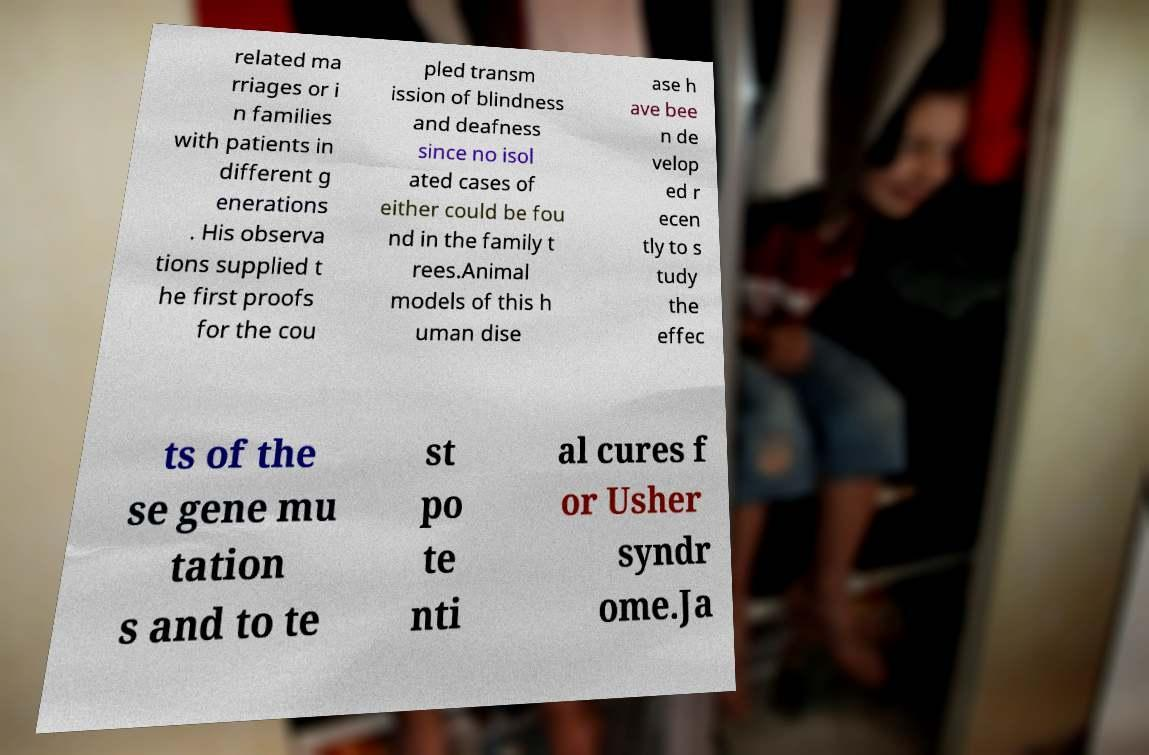There's text embedded in this image that I need extracted. Can you transcribe it verbatim? related ma rriages or i n families with patients in different g enerations . His observa tions supplied t he first proofs for the cou pled transm ission of blindness and deafness since no isol ated cases of either could be fou nd in the family t rees.Animal models of this h uman dise ase h ave bee n de velop ed r ecen tly to s tudy the effec ts of the se gene mu tation s and to te st po te nti al cures f or Usher syndr ome.Ja 